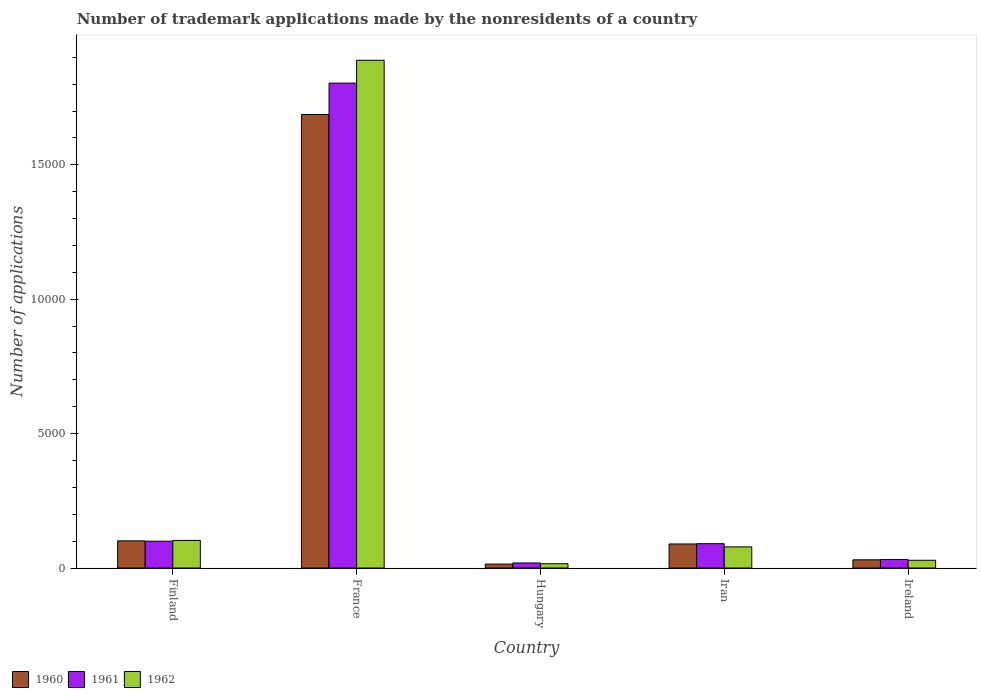How many groups of bars are there?
Offer a very short reply. 5. Are the number of bars per tick equal to the number of legend labels?
Ensure brevity in your answer.  Yes. How many bars are there on the 5th tick from the right?
Provide a succinct answer. 3. What is the label of the 2nd group of bars from the left?
Offer a very short reply. France. What is the number of trademark applications made by the nonresidents in 1960 in Hungary?
Provide a succinct answer. 147. Across all countries, what is the maximum number of trademark applications made by the nonresidents in 1962?
Your response must be concise. 1.89e+04. Across all countries, what is the minimum number of trademark applications made by the nonresidents in 1961?
Your answer should be compact. 188. In which country was the number of trademark applications made by the nonresidents in 1961 minimum?
Keep it short and to the point. Hungary. What is the total number of trademark applications made by the nonresidents in 1961 in the graph?
Ensure brevity in your answer.  2.04e+04. What is the difference between the number of trademark applications made by the nonresidents in 1961 in Iran and that in Ireland?
Offer a very short reply. 589. What is the difference between the number of trademark applications made by the nonresidents in 1961 in Ireland and the number of trademark applications made by the nonresidents in 1962 in Finland?
Make the answer very short. -711. What is the average number of trademark applications made by the nonresidents in 1960 per country?
Keep it short and to the point. 3846.4. What is the ratio of the number of trademark applications made by the nonresidents in 1962 in Hungary to that in Ireland?
Provide a short and direct response. 0.55. Is the number of trademark applications made by the nonresidents in 1962 in Finland less than that in Hungary?
Your response must be concise. No. What is the difference between the highest and the second highest number of trademark applications made by the nonresidents in 1962?
Keep it short and to the point. -241. What is the difference between the highest and the lowest number of trademark applications made by the nonresidents in 1960?
Offer a very short reply. 1.67e+04. In how many countries, is the number of trademark applications made by the nonresidents in 1962 greater than the average number of trademark applications made by the nonresidents in 1962 taken over all countries?
Provide a short and direct response. 1. Is the sum of the number of trademark applications made by the nonresidents in 1961 in France and Hungary greater than the maximum number of trademark applications made by the nonresidents in 1960 across all countries?
Offer a terse response. Yes. Is it the case that in every country, the sum of the number of trademark applications made by the nonresidents in 1962 and number of trademark applications made by the nonresidents in 1960 is greater than the number of trademark applications made by the nonresidents in 1961?
Ensure brevity in your answer.  Yes. How many bars are there?
Offer a terse response. 15. Are all the bars in the graph horizontal?
Your response must be concise. No. How many countries are there in the graph?
Provide a short and direct response. 5. What is the difference between two consecutive major ticks on the Y-axis?
Make the answer very short. 5000. Are the values on the major ticks of Y-axis written in scientific E-notation?
Provide a succinct answer. No. Does the graph contain any zero values?
Offer a terse response. No. Does the graph contain grids?
Provide a succinct answer. No. How many legend labels are there?
Keep it short and to the point. 3. What is the title of the graph?
Ensure brevity in your answer.  Number of trademark applications made by the nonresidents of a country. Does "2006" appear as one of the legend labels in the graph?
Provide a succinct answer. No. What is the label or title of the Y-axis?
Your answer should be very brief. Number of applications. What is the Number of applications of 1960 in Finland?
Keep it short and to the point. 1011. What is the Number of applications of 1961 in Finland?
Offer a terse response. 998. What is the Number of applications of 1962 in Finland?
Your answer should be very brief. 1027. What is the Number of applications of 1960 in France?
Your response must be concise. 1.69e+04. What is the Number of applications in 1961 in France?
Offer a terse response. 1.80e+04. What is the Number of applications in 1962 in France?
Provide a short and direct response. 1.89e+04. What is the Number of applications of 1960 in Hungary?
Give a very brief answer. 147. What is the Number of applications in 1961 in Hungary?
Offer a terse response. 188. What is the Number of applications in 1962 in Hungary?
Your answer should be very brief. 158. What is the Number of applications in 1960 in Iran?
Keep it short and to the point. 895. What is the Number of applications in 1961 in Iran?
Provide a short and direct response. 905. What is the Number of applications in 1962 in Iran?
Your answer should be very brief. 786. What is the Number of applications in 1960 in Ireland?
Your answer should be compact. 305. What is the Number of applications in 1961 in Ireland?
Make the answer very short. 316. What is the Number of applications of 1962 in Ireland?
Offer a terse response. 288. Across all countries, what is the maximum Number of applications of 1960?
Offer a very short reply. 1.69e+04. Across all countries, what is the maximum Number of applications of 1961?
Give a very brief answer. 1.80e+04. Across all countries, what is the maximum Number of applications of 1962?
Provide a short and direct response. 1.89e+04. Across all countries, what is the minimum Number of applications of 1960?
Make the answer very short. 147. Across all countries, what is the minimum Number of applications in 1961?
Keep it short and to the point. 188. Across all countries, what is the minimum Number of applications in 1962?
Ensure brevity in your answer.  158. What is the total Number of applications of 1960 in the graph?
Offer a terse response. 1.92e+04. What is the total Number of applications in 1961 in the graph?
Make the answer very short. 2.04e+04. What is the total Number of applications of 1962 in the graph?
Make the answer very short. 2.12e+04. What is the difference between the Number of applications of 1960 in Finland and that in France?
Your answer should be compact. -1.59e+04. What is the difference between the Number of applications in 1961 in Finland and that in France?
Provide a succinct answer. -1.70e+04. What is the difference between the Number of applications of 1962 in Finland and that in France?
Make the answer very short. -1.79e+04. What is the difference between the Number of applications of 1960 in Finland and that in Hungary?
Keep it short and to the point. 864. What is the difference between the Number of applications in 1961 in Finland and that in Hungary?
Offer a terse response. 810. What is the difference between the Number of applications in 1962 in Finland and that in Hungary?
Ensure brevity in your answer.  869. What is the difference between the Number of applications of 1960 in Finland and that in Iran?
Your answer should be compact. 116. What is the difference between the Number of applications of 1961 in Finland and that in Iran?
Ensure brevity in your answer.  93. What is the difference between the Number of applications in 1962 in Finland and that in Iran?
Your answer should be compact. 241. What is the difference between the Number of applications of 1960 in Finland and that in Ireland?
Offer a terse response. 706. What is the difference between the Number of applications in 1961 in Finland and that in Ireland?
Your answer should be very brief. 682. What is the difference between the Number of applications of 1962 in Finland and that in Ireland?
Your response must be concise. 739. What is the difference between the Number of applications of 1960 in France and that in Hungary?
Offer a very short reply. 1.67e+04. What is the difference between the Number of applications of 1961 in France and that in Hungary?
Keep it short and to the point. 1.79e+04. What is the difference between the Number of applications in 1962 in France and that in Hungary?
Offer a terse response. 1.87e+04. What is the difference between the Number of applications of 1960 in France and that in Iran?
Offer a very short reply. 1.60e+04. What is the difference between the Number of applications in 1961 in France and that in Iran?
Provide a succinct answer. 1.71e+04. What is the difference between the Number of applications of 1962 in France and that in Iran?
Your response must be concise. 1.81e+04. What is the difference between the Number of applications of 1960 in France and that in Ireland?
Your answer should be compact. 1.66e+04. What is the difference between the Number of applications of 1961 in France and that in Ireland?
Make the answer very short. 1.77e+04. What is the difference between the Number of applications in 1962 in France and that in Ireland?
Your response must be concise. 1.86e+04. What is the difference between the Number of applications of 1960 in Hungary and that in Iran?
Your answer should be compact. -748. What is the difference between the Number of applications of 1961 in Hungary and that in Iran?
Provide a short and direct response. -717. What is the difference between the Number of applications in 1962 in Hungary and that in Iran?
Give a very brief answer. -628. What is the difference between the Number of applications in 1960 in Hungary and that in Ireland?
Your response must be concise. -158. What is the difference between the Number of applications of 1961 in Hungary and that in Ireland?
Make the answer very short. -128. What is the difference between the Number of applications in 1962 in Hungary and that in Ireland?
Ensure brevity in your answer.  -130. What is the difference between the Number of applications of 1960 in Iran and that in Ireland?
Ensure brevity in your answer.  590. What is the difference between the Number of applications of 1961 in Iran and that in Ireland?
Ensure brevity in your answer.  589. What is the difference between the Number of applications of 1962 in Iran and that in Ireland?
Ensure brevity in your answer.  498. What is the difference between the Number of applications of 1960 in Finland and the Number of applications of 1961 in France?
Ensure brevity in your answer.  -1.70e+04. What is the difference between the Number of applications of 1960 in Finland and the Number of applications of 1962 in France?
Give a very brief answer. -1.79e+04. What is the difference between the Number of applications in 1961 in Finland and the Number of applications in 1962 in France?
Keep it short and to the point. -1.79e+04. What is the difference between the Number of applications of 1960 in Finland and the Number of applications of 1961 in Hungary?
Ensure brevity in your answer.  823. What is the difference between the Number of applications in 1960 in Finland and the Number of applications in 1962 in Hungary?
Offer a terse response. 853. What is the difference between the Number of applications of 1961 in Finland and the Number of applications of 1962 in Hungary?
Keep it short and to the point. 840. What is the difference between the Number of applications in 1960 in Finland and the Number of applications in 1961 in Iran?
Provide a short and direct response. 106. What is the difference between the Number of applications in 1960 in Finland and the Number of applications in 1962 in Iran?
Your response must be concise. 225. What is the difference between the Number of applications of 1961 in Finland and the Number of applications of 1962 in Iran?
Offer a very short reply. 212. What is the difference between the Number of applications in 1960 in Finland and the Number of applications in 1961 in Ireland?
Keep it short and to the point. 695. What is the difference between the Number of applications in 1960 in Finland and the Number of applications in 1962 in Ireland?
Offer a very short reply. 723. What is the difference between the Number of applications of 1961 in Finland and the Number of applications of 1962 in Ireland?
Ensure brevity in your answer.  710. What is the difference between the Number of applications in 1960 in France and the Number of applications in 1961 in Hungary?
Your answer should be very brief. 1.67e+04. What is the difference between the Number of applications of 1960 in France and the Number of applications of 1962 in Hungary?
Your answer should be compact. 1.67e+04. What is the difference between the Number of applications of 1961 in France and the Number of applications of 1962 in Hungary?
Offer a very short reply. 1.79e+04. What is the difference between the Number of applications in 1960 in France and the Number of applications in 1961 in Iran?
Provide a succinct answer. 1.60e+04. What is the difference between the Number of applications in 1960 in France and the Number of applications in 1962 in Iran?
Offer a terse response. 1.61e+04. What is the difference between the Number of applications in 1961 in France and the Number of applications in 1962 in Iran?
Your answer should be compact. 1.73e+04. What is the difference between the Number of applications in 1960 in France and the Number of applications in 1961 in Ireland?
Keep it short and to the point. 1.66e+04. What is the difference between the Number of applications in 1960 in France and the Number of applications in 1962 in Ireland?
Ensure brevity in your answer.  1.66e+04. What is the difference between the Number of applications in 1961 in France and the Number of applications in 1962 in Ireland?
Give a very brief answer. 1.78e+04. What is the difference between the Number of applications of 1960 in Hungary and the Number of applications of 1961 in Iran?
Provide a short and direct response. -758. What is the difference between the Number of applications of 1960 in Hungary and the Number of applications of 1962 in Iran?
Make the answer very short. -639. What is the difference between the Number of applications of 1961 in Hungary and the Number of applications of 1962 in Iran?
Keep it short and to the point. -598. What is the difference between the Number of applications in 1960 in Hungary and the Number of applications in 1961 in Ireland?
Give a very brief answer. -169. What is the difference between the Number of applications in 1960 in Hungary and the Number of applications in 1962 in Ireland?
Offer a terse response. -141. What is the difference between the Number of applications of 1961 in Hungary and the Number of applications of 1962 in Ireland?
Provide a short and direct response. -100. What is the difference between the Number of applications in 1960 in Iran and the Number of applications in 1961 in Ireland?
Make the answer very short. 579. What is the difference between the Number of applications in 1960 in Iran and the Number of applications in 1962 in Ireland?
Give a very brief answer. 607. What is the difference between the Number of applications in 1961 in Iran and the Number of applications in 1962 in Ireland?
Ensure brevity in your answer.  617. What is the average Number of applications in 1960 per country?
Keep it short and to the point. 3846.4. What is the average Number of applications of 1961 per country?
Offer a terse response. 4089.8. What is the average Number of applications of 1962 per country?
Your response must be concise. 4230.2. What is the difference between the Number of applications of 1960 and Number of applications of 1961 in Finland?
Provide a succinct answer. 13. What is the difference between the Number of applications of 1961 and Number of applications of 1962 in Finland?
Offer a terse response. -29. What is the difference between the Number of applications in 1960 and Number of applications in 1961 in France?
Offer a very short reply. -1168. What is the difference between the Number of applications in 1960 and Number of applications in 1962 in France?
Ensure brevity in your answer.  -2018. What is the difference between the Number of applications in 1961 and Number of applications in 1962 in France?
Give a very brief answer. -850. What is the difference between the Number of applications of 1960 and Number of applications of 1961 in Hungary?
Give a very brief answer. -41. What is the difference between the Number of applications of 1961 and Number of applications of 1962 in Hungary?
Your answer should be compact. 30. What is the difference between the Number of applications of 1960 and Number of applications of 1962 in Iran?
Offer a very short reply. 109. What is the difference between the Number of applications of 1961 and Number of applications of 1962 in Iran?
Provide a short and direct response. 119. What is the difference between the Number of applications of 1960 and Number of applications of 1962 in Ireland?
Offer a terse response. 17. What is the ratio of the Number of applications of 1960 in Finland to that in France?
Ensure brevity in your answer.  0.06. What is the ratio of the Number of applications in 1961 in Finland to that in France?
Make the answer very short. 0.06. What is the ratio of the Number of applications of 1962 in Finland to that in France?
Offer a terse response. 0.05. What is the ratio of the Number of applications in 1960 in Finland to that in Hungary?
Your answer should be very brief. 6.88. What is the ratio of the Number of applications of 1961 in Finland to that in Hungary?
Provide a succinct answer. 5.31. What is the ratio of the Number of applications of 1960 in Finland to that in Iran?
Your response must be concise. 1.13. What is the ratio of the Number of applications in 1961 in Finland to that in Iran?
Make the answer very short. 1.1. What is the ratio of the Number of applications of 1962 in Finland to that in Iran?
Offer a terse response. 1.31. What is the ratio of the Number of applications of 1960 in Finland to that in Ireland?
Your response must be concise. 3.31. What is the ratio of the Number of applications in 1961 in Finland to that in Ireland?
Offer a terse response. 3.16. What is the ratio of the Number of applications in 1962 in Finland to that in Ireland?
Your answer should be very brief. 3.57. What is the ratio of the Number of applications in 1960 in France to that in Hungary?
Your answer should be very brief. 114.79. What is the ratio of the Number of applications of 1961 in France to that in Hungary?
Provide a succinct answer. 95.97. What is the ratio of the Number of applications of 1962 in France to that in Hungary?
Provide a succinct answer. 119.57. What is the ratio of the Number of applications in 1960 in France to that in Iran?
Give a very brief answer. 18.85. What is the ratio of the Number of applications of 1961 in France to that in Iran?
Make the answer very short. 19.94. What is the ratio of the Number of applications of 1962 in France to that in Iran?
Keep it short and to the point. 24.04. What is the ratio of the Number of applications in 1960 in France to that in Ireland?
Provide a short and direct response. 55.32. What is the ratio of the Number of applications in 1961 in France to that in Ireland?
Ensure brevity in your answer.  57.09. What is the ratio of the Number of applications in 1962 in France to that in Ireland?
Your answer should be very brief. 65.6. What is the ratio of the Number of applications of 1960 in Hungary to that in Iran?
Keep it short and to the point. 0.16. What is the ratio of the Number of applications of 1961 in Hungary to that in Iran?
Your answer should be compact. 0.21. What is the ratio of the Number of applications in 1962 in Hungary to that in Iran?
Provide a succinct answer. 0.2. What is the ratio of the Number of applications of 1960 in Hungary to that in Ireland?
Provide a succinct answer. 0.48. What is the ratio of the Number of applications in 1961 in Hungary to that in Ireland?
Offer a terse response. 0.59. What is the ratio of the Number of applications in 1962 in Hungary to that in Ireland?
Provide a succinct answer. 0.55. What is the ratio of the Number of applications in 1960 in Iran to that in Ireland?
Your response must be concise. 2.93. What is the ratio of the Number of applications in 1961 in Iran to that in Ireland?
Keep it short and to the point. 2.86. What is the ratio of the Number of applications of 1962 in Iran to that in Ireland?
Keep it short and to the point. 2.73. What is the difference between the highest and the second highest Number of applications in 1960?
Ensure brevity in your answer.  1.59e+04. What is the difference between the highest and the second highest Number of applications of 1961?
Ensure brevity in your answer.  1.70e+04. What is the difference between the highest and the second highest Number of applications in 1962?
Ensure brevity in your answer.  1.79e+04. What is the difference between the highest and the lowest Number of applications of 1960?
Your response must be concise. 1.67e+04. What is the difference between the highest and the lowest Number of applications of 1961?
Your response must be concise. 1.79e+04. What is the difference between the highest and the lowest Number of applications of 1962?
Your answer should be very brief. 1.87e+04. 